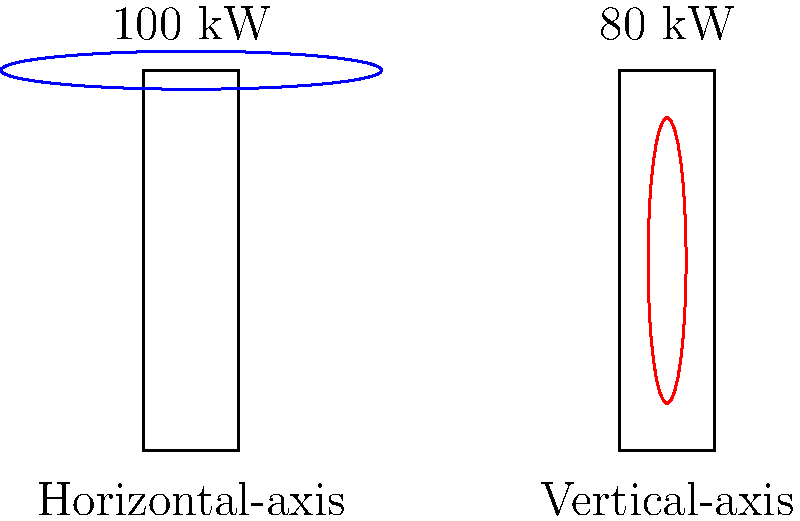Based on the simplified diagram comparing horizontal-axis and vertical-axis wind turbines, which type typically has a higher power output, and by what percentage? To determine the difference in power output between horizontal-axis and vertical-axis wind turbines:

1. Identify the power outputs:
   - Horizontal-axis: 100 kW
   - Vertical-axis: 80 kW

2. Calculate the difference:
   $100 \text{ kW} - 80 \text{ kW} = 20 \text{ kW}$

3. Calculate the percentage difference:
   $$\text{Percentage difference} = \frac{\text{Difference}}{\text{Lower value}} \times 100\%$$
   $$= \frac{20 \text{ kW}}{80 \text{ kW}} \times 100\% = 25\%$$

4. Determine which type has higher output:
   The horizontal-axis turbine has a higher power output.

Therefore, the horizontal-axis wind turbine typically has a 25% higher power output compared to the vertical-axis wind turbine.
Answer: Horizontal-axis, 25% higher 